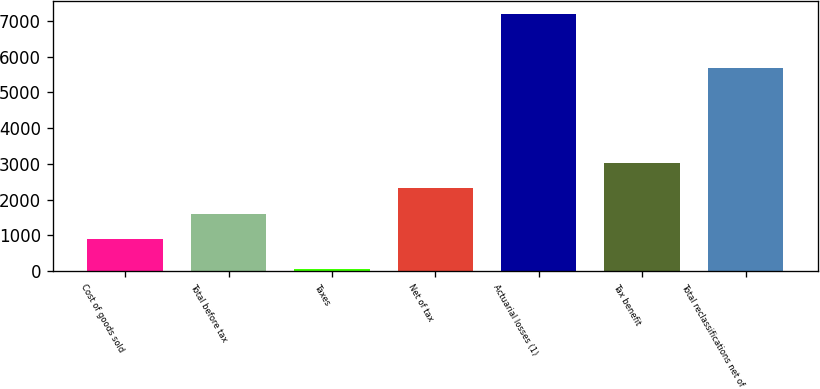Convert chart. <chart><loc_0><loc_0><loc_500><loc_500><bar_chart><fcel>Cost of goods sold<fcel>Total before tax<fcel>Taxes<fcel>Net of tax<fcel>Actuarial losses (1)<fcel>Tax benefit<fcel>Total reclassifications net of<nl><fcel>884<fcel>1600.5<fcel>46<fcel>2317<fcel>7211<fcel>3033.5<fcel>5686<nl></chart> 